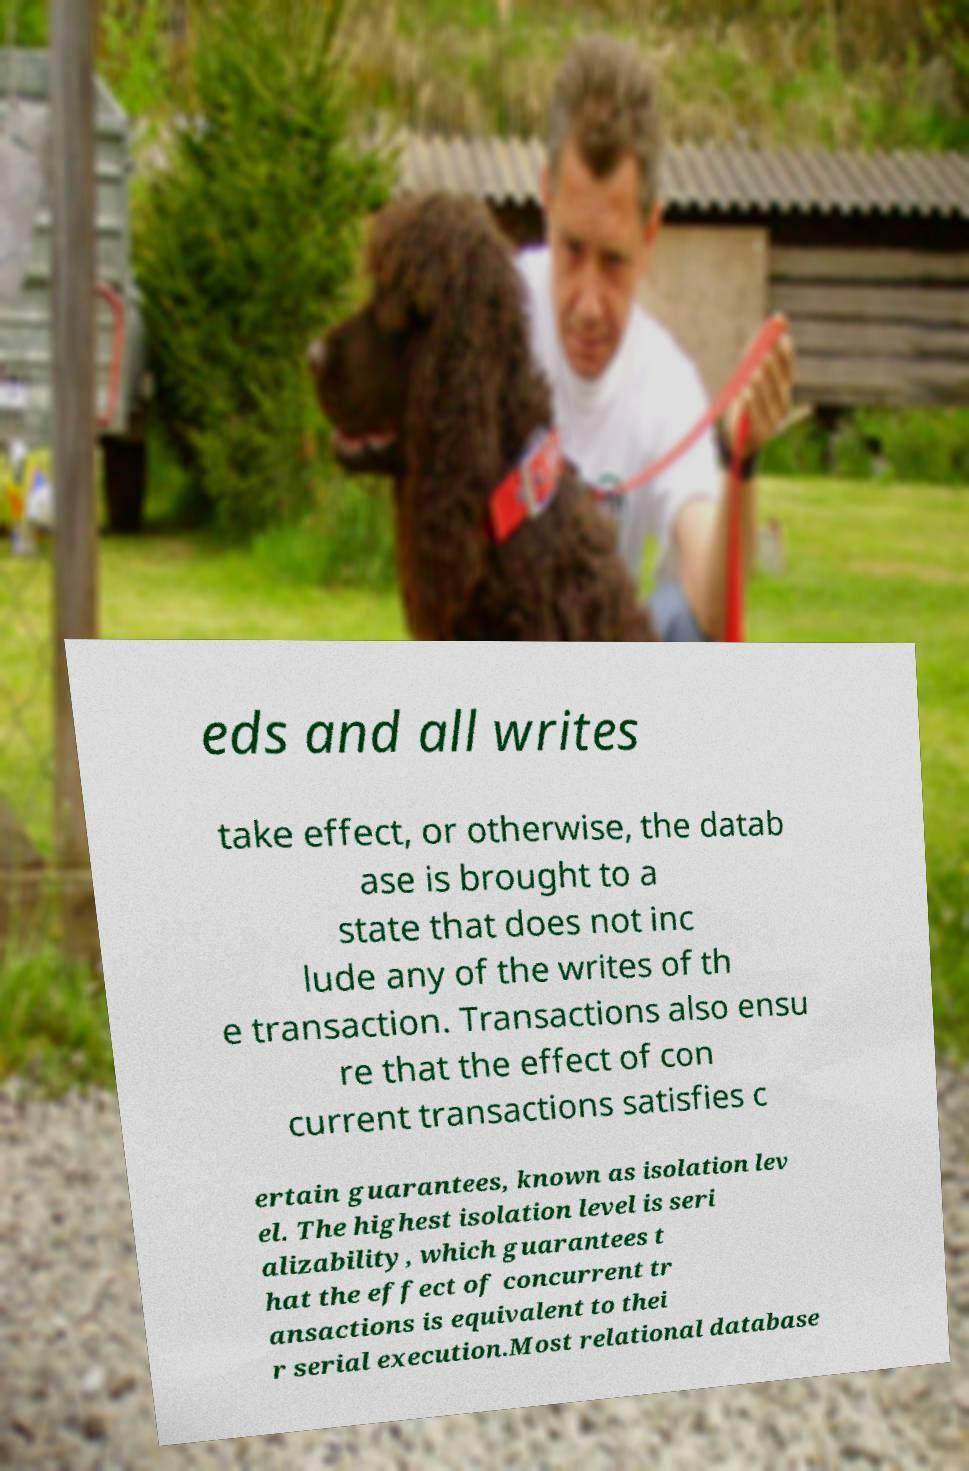Could you assist in decoding the text presented in this image and type it out clearly? eds and all writes take effect, or otherwise, the datab ase is brought to a state that does not inc lude any of the writes of th e transaction. Transactions also ensu re that the effect of con current transactions satisfies c ertain guarantees, known as isolation lev el. The highest isolation level is seri alizability, which guarantees t hat the effect of concurrent tr ansactions is equivalent to thei r serial execution.Most relational database 